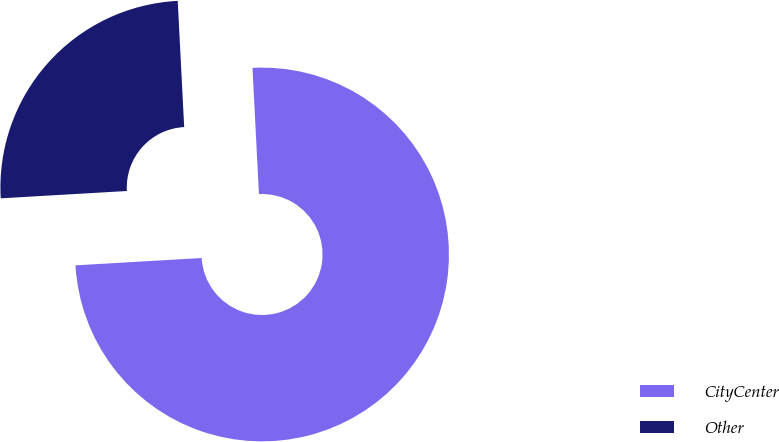<chart> <loc_0><loc_0><loc_500><loc_500><pie_chart><fcel>CityCenter<fcel>Other<nl><fcel>74.89%<fcel>25.11%<nl></chart> 